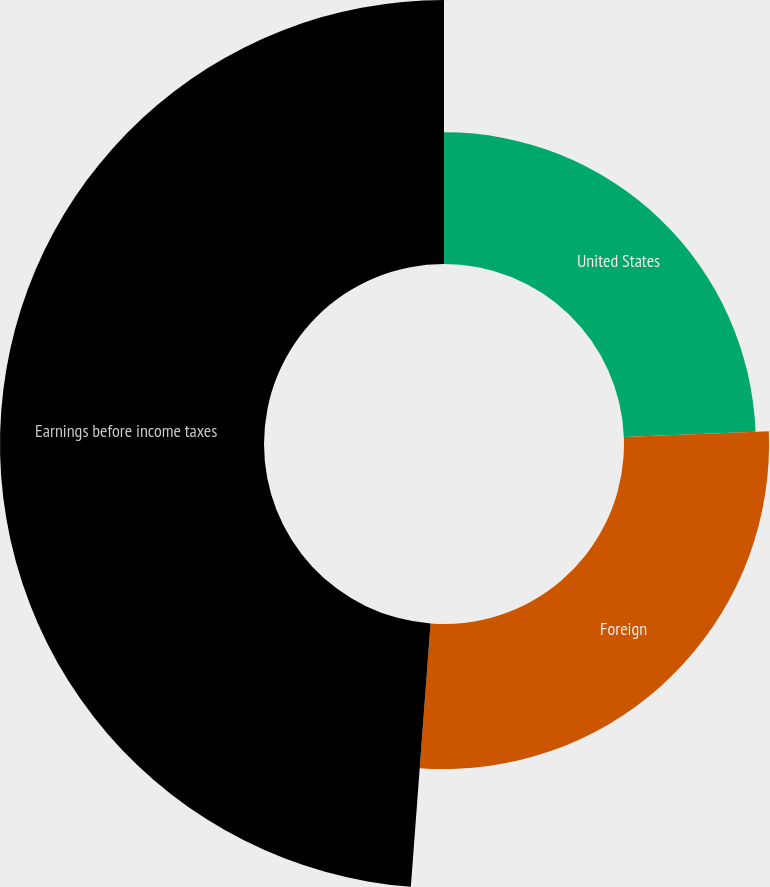<chart> <loc_0><loc_0><loc_500><loc_500><pie_chart><fcel>United States<fcel>Foreign<fcel>Earnings before income taxes<nl><fcel>24.37%<fcel>26.82%<fcel>48.81%<nl></chart> 